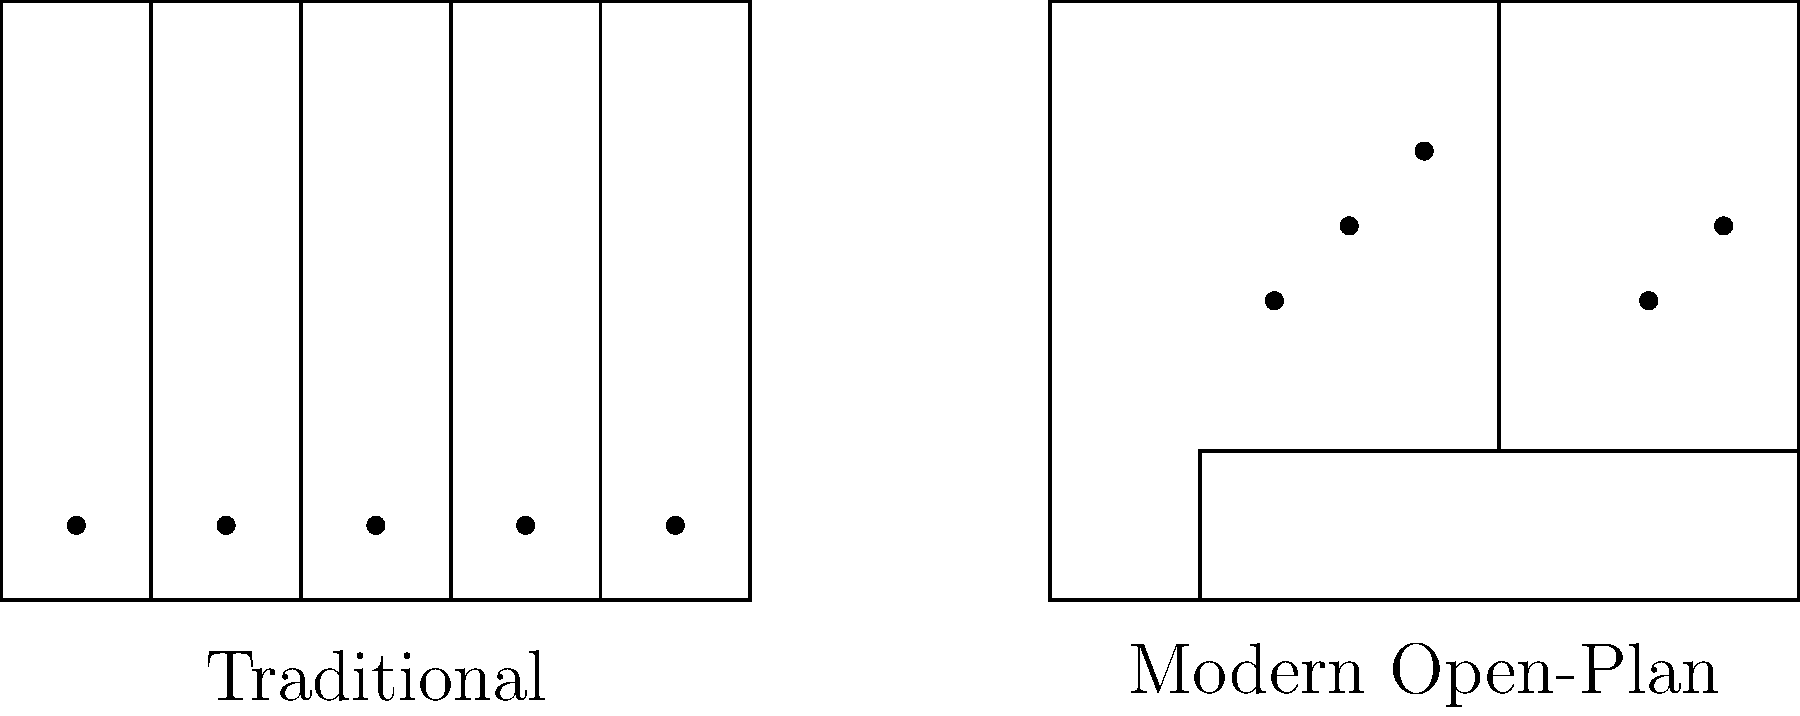Based on the floor plans shown, which layout allows for more efficient use of space in terms of accommodating the same number of employees? To determine which layout allows for more efficient use of space, we need to analyze both floor plans:

1. Traditional Office Layout:
   - Divided into 5 equal-sized individual offices
   - Each office can accommodate 1 employee
   - Total capacity: 5 employees

2. Modern Open-Plan Layout:
   - Large open area with minimal partitions
   - Can accommodate at least 5 employees (as shown by the dots representing people)
   - Potential for more flexible seating arrangements

3. Space Efficiency Comparison:
   - Both layouts occupy the same total area (5 units x 4 units)
   - Traditional layout uses fixed space for each employee
   - Open-plan layout allows for more flexible use of space

4. Flexibility and Scalability:
   - Traditional layout is limited to 5 employees without structural changes
   - Open-plan layout can potentially accommodate more employees by adjusting seating arrangements

5. Conclusion:
   While both layouts can accommodate the same number of employees in this example, the modern open-plan design allows for more efficient use of space due to its flexibility and potential for increased capacity without structural changes.
Answer: Modern Open-Plan layout 